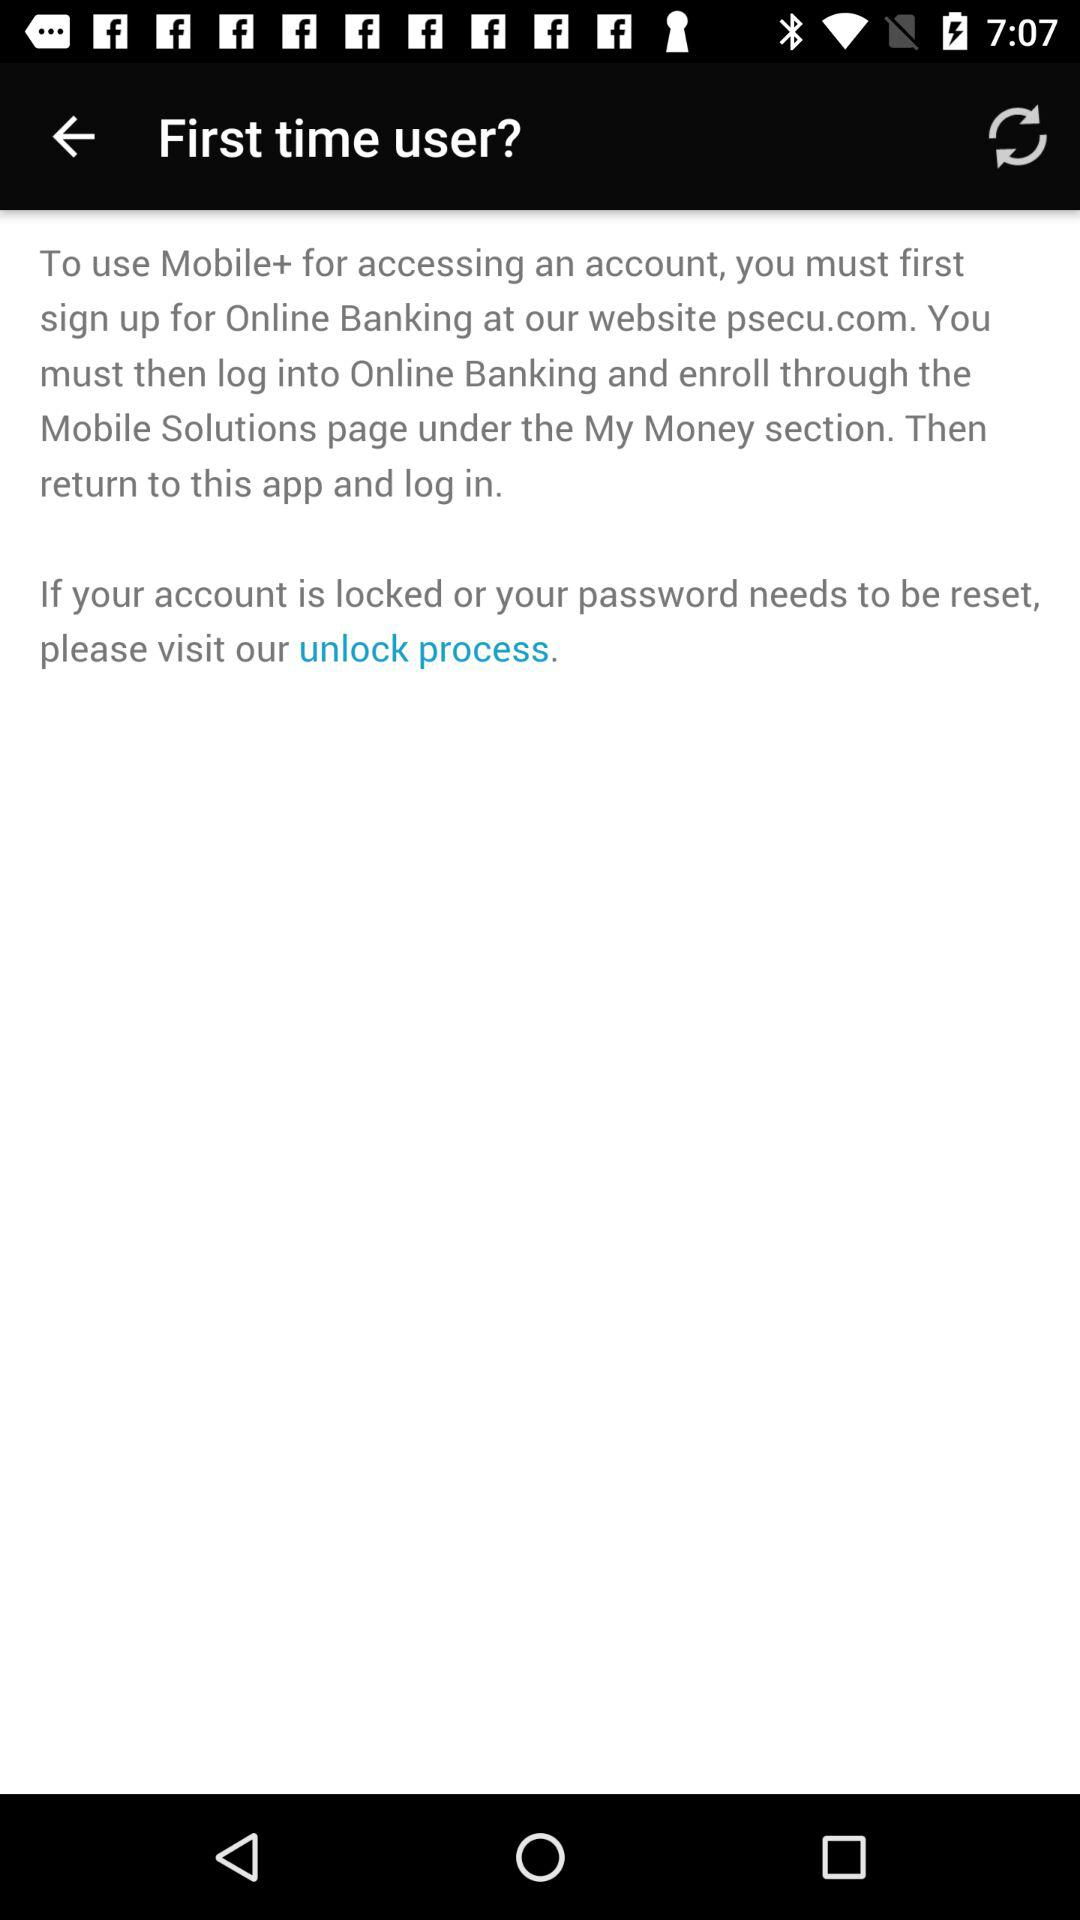How many steps are there in the process?
Answer the question using a single word or phrase. 3 